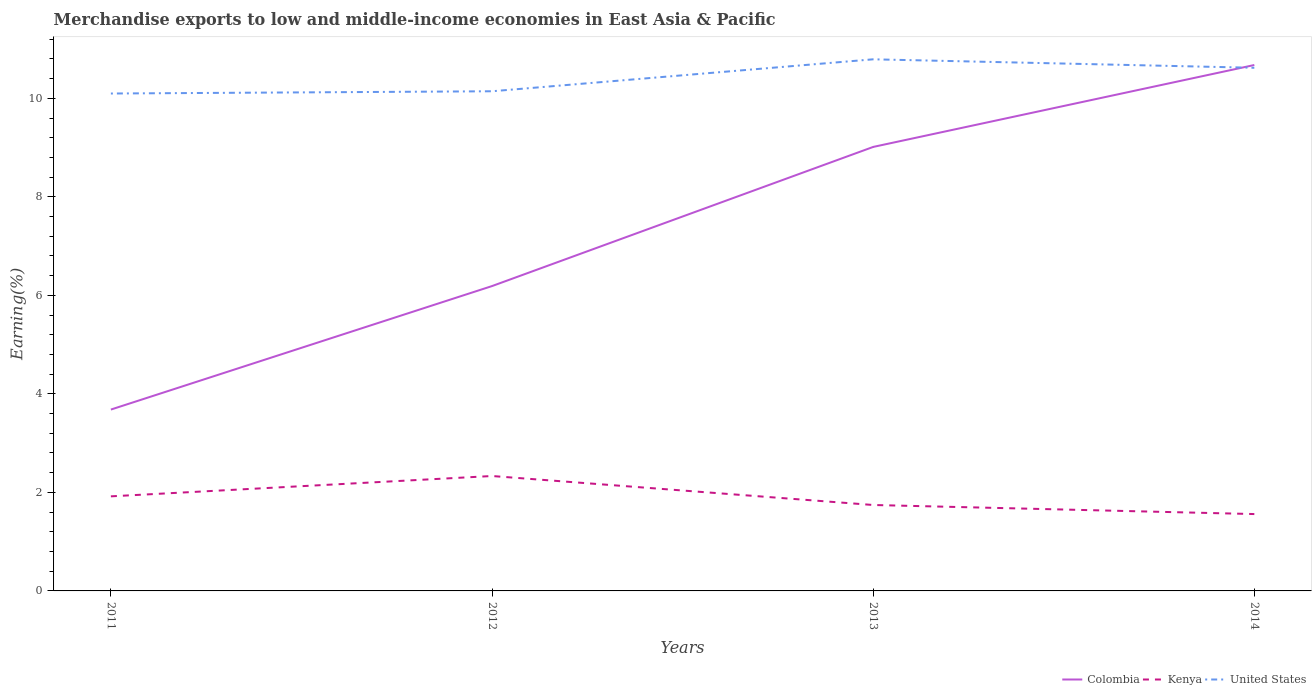Does the line corresponding to Kenya intersect with the line corresponding to Colombia?
Provide a short and direct response. No. Across all years, what is the maximum percentage of amount earned from merchandise exports in United States?
Provide a succinct answer. 10.1. What is the total percentage of amount earned from merchandise exports in United States in the graph?
Offer a very short reply. -0.65. What is the difference between the highest and the second highest percentage of amount earned from merchandise exports in Colombia?
Offer a very short reply. 6.99. What is the difference between the highest and the lowest percentage of amount earned from merchandise exports in Kenya?
Your answer should be very brief. 2. Is the percentage of amount earned from merchandise exports in United States strictly greater than the percentage of amount earned from merchandise exports in Colombia over the years?
Offer a terse response. No. How many lines are there?
Provide a succinct answer. 3. Are the values on the major ticks of Y-axis written in scientific E-notation?
Your answer should be compact. No. Where does the legend appear in the graph?
Keep it short and to the point. Bottom right. How are the legend labels stacked?
Make the answer very short. Horizontal. What is the title of the graph?
Provide a short and direct response. Merchandise exports to low and middle-income economies in East Asia & Pacific. What is the label or title of the X-axis?
Your answer should be compact. Years. What is the label or title of the Y-axis?
Your response must be concise. Earning(%). What is the Earning(%) in Colombia in 2011?
Provide a short and direct response. 3.68. What is the Earning(%) in Kenya in 2011?
Make the answer very short. 1.92. What is the Earning(%) in United States in 2011?
Provide a short and direct response. 10.1. What is the Earning(%) in Colombia in 2012?
Make the answer very short. 6.19. What is the Earning(%) in Kenya in 2012?
Your response must be concise. 2.33. What is the Earning(%) of United States in 2012?
Your answer should be compact. 10.14. What is the Earning(%) of Colombia in 2013?
Offer a very short reply. 9.01. What is the Earning(%) in Kenya in 2013?
Your response must be concise. 1.74. What is the Earning(%) of United States in 2013?
Provide a succinct answer. 10.79. What is the Earning(%) in Colombia in 2014?
Offer a terse response. 10.68. What is the Earning(%) in Kenya in 2014?
Your response must be concise. 1.56. What is the Earning(%) of United States in 2014?
Ensure brevity in your answer.  10.62. Across all years, what is the maximum Earning(%) of Colombia?
Provide a succinct answer. 10.68. Across all years, what is the maximum Earning(%) of Kenya?
Provide a short and direct response. 2.33. Across all years, what is the maximum Earning(%) in United States?
Make the answer very short. 10.79. Across all years, what is the minimum Earning(%) of Colombia?
Your answer should be compact. 3.68. Across all years, what is the minimum Earning(%) of Kenya?
Keep it short and to the point. 1.56. Across all years, what is the minimum Earning(%) of United States?
Offer a very short reply. 10.1. What is the total Earning(%) of Colombia in the graph?
Your response must be concise. 29.56. What is the total Earning(%) of Kenya in the graph?
Your response must be concise. 7.56. What is the total Earning(%) of United States in the graph?
Your response must be concise. 41.65. What is the difference between the Earning(%) in Colombia in 2011 and that in 2012?
Keep it short and to the point. -2.51. What is the difference between the Earning(%) in Kenya in 2011 and that in 2012?
Provide a succinct answer. -0.41. What is the difference between the Earning(%) in United States in 2011 and that in 2012?
Provide a short and direct response. -0.05. What is the difference between the Earning(%) in Colombia in 2011 and that in 2013?
Your response must be concise. -5.33. What is the difference between the Earning(%) of Kenya in 2011 and that in 2013?
Offer a very short reply. 0.18. What is the difference between the Earning(%) in United States in 2011 and that in 2013?
Ensure brevity in your answer.  -0.69. What is the difference between the Earning(%) of Colombia in 2011 and that in 2014?
Offer a terse response. -6.99. What is the difference between the Earning(%) of Kenya in 2011 and that in 2014?
Your answer should be very brief. 0.36. What is the difference between the Earning(%) in United States in 2011 and that in 2014?
Your answer should be compact. -0.52. What is the difference between the Earning(%) of Colombia in 2012 and that in 2013?
Offer a very short reply. -2.82. What is the difference between the Earning(%) of Kenya in 2012 and that in 2013?
Ensure brevity in your answer.  0.59. What is the difference between the Earning(%) in United States in 2012 and that in 2013?
Give a very brief answer. -0.65. What is the difference between the Earning(%) of Colombia in 2012 and that in 2014?
Provide a succinct answer. -4.49. What is the difference between the Earning(%) in Kenya in 2012 and that in 2014?
Ensure brevity in your answer.  0.77. What is the difference between the Earning(%) of United States in 2012 and that in 2014?
Provide a succinct answer. -0.48. What is the difference between the Earning(%) in Colombia in 2013 and that in 2014?
Offer a very short reply. -1.66. What is the difference between the Earning(%) in Kenya in 2013 and that in 2014?
Provide a succinct answer. 0.18. What is the difference between the Earning(%) of United States in 2013 and that in 2014?
Keep it short and to the point. 0.17. What is the difference between the Earning(%) of Colombia in 2011 and the Earning(%) of Kenya in 2012?
Provide a succinct answer. 1.35. What is the difference between the Earning(%) in Colombia in 2011 and the Earning(%) in United States in 2012?
Your answer should be very brief. -6.46. What is the difference between the Earning(%) of Kenya in 2011 and the Earning(%) of United States in 2012?
Offer a terse response. -8.22. What is the difference between the Earning(%) of Colombia in 2011 and the Earning(%) of Kenya in 2013?
Your answer should be compact. 1.94. What is the difference between the Earning(%) of Colombia in 2011 and the Earning(%) of United States in 2013?
Provide a succinct answer. -7.11. What is the difference between the Earning(%) in Kenya in 2011 and the Earning(%) in United States in 2013?
Ensure brevity in your answer.  -8.87. What is the difference between the Earning(%) of Colombia in 2011 and the Earning(%) of Kenya in 2014?
Provide a short and direct response. 2.12. What is the difference between the Earning(%) in Colombia in 2011 and the Earning(%) in United States in 2014?
Your response must be concise. -6.94. What is the difference between the Earning(%) in Kenya in 2011 and the Earning(%) in United States in 2014?
Keep it short and to the point. -8.7. What is the difference between the Earning(%) in Colombia in 2012 and the Earning(%) in Kenya in 2013?
Give a very brief answer. 4.44. What is the difference between the Earning(%) of Colombia in 2012 and the Earning(%) of United States in 2013?
Give a very brief answer. -4.6. What is the difference between the Earning(%) of Kenya in 2012 and the Earning(%) of United States in 2013?
Keep it short and to the point. -8.46. What is the difference between the Earning(%) in Colombia in 2012 and the Earning(%) in Kenya in 2014?
Provide a short and direct response. 4.63. What is the difference between the Earning(%) of Colombia in 2012 and the Earning(%) of United States in 2014?
Provide a short and direct response. -4.43. What is the difference between the Earning(%) of Kenya in 2012 and the Earning(%) of United States in 2014?
Your answer should be very brief. -8.29. What is the difference between the Earning(%) in Colombia in 2013 and the Earning(%) in Kenya in 2014?
Make the answer very short. 7.45. What is the difference between the Earning(%) of Colombia in 2013 and the Earning(%) of United States in 2014?
Your answer should be compact. -1.61. What is the difference between the Earning(%) in Kenya in 2013 and the Earning(%) in United States in 2014?
Keep it short and to the point. -8.88. What is the average Earning(%) of Colombia per year?
Give a very brief answer. 7.39. What is the average Earning(%) in Kenya per year?
Your answer should be very brief. 1.89. What is the average Earning(%) in United States per year?
Offer a very short reply. 10.41. In the year 2011, what is the difference between the Earning(%) in Colombia and Earning(%) in Kenya?
Ensure brevity in your answer.  1.76. In the year 2011, what is the difference between the Earning(%) in Colombia and Earning(%) in United States?
Provide a succinct answer. -6.42. In the year 2011, what is the difference between the Earning(%) in Kenya and Earning(%) in United States?
Keep it short and to the point. -8.18. In the year 2012, what is the difference between the Earning(%) of Colombia and Earning(%) of Kenya?
Offer a very short reply. 3.86. In the year 2012, what is the difference between the Earning(%) in Colombia and Earning(%) in United States?
Ensure brevity in your answer.  -3.95. In the year 2012, what is the difference between the Earning(%) of Kenya and Earning(%) of United States?
Offer a very short reply. -7.81. In the year 2013, what is the difference between the Earning(%) of Colombia and Earning(%) of Kenya?
Your answer should be compact. 7.27. In the year 2013, what is the difference between the Earning(%) in Colombia and Earning(%) in United States?
Your response must be concise. -1.78. In the year 2013, what is the difference between the Earning(%) of Kenya and Earning(%) of United States?
Your response must be concise. -9.05. In the year 2014, what is the difference between the Earning(%) of Colombia and Earning(%) of Kenya?
Give a very brief answer. 9.12. In the year 2014, what is the difference between the Earning(%) in Colombia and Earning(%) in United States?
Offer a terse response. 0.06. In the year 2014, what is the difference between the Earning(%) of Kenya and Earning(%) of United States?
Make the answer very short. -9.06. What is the ratio of the Earning(%) of Colombia in 2011 to that in 2012?
Provide a succinct answer. 0.59. What is the ratio of the Earning(%) of Kenya in 2011 to that in 2012?
Make the answer very short. 0.82. What is the ratio of the Earning(%) of Colombia in 2011 to that in 2013?
Your answer should be compact. 0.41. What is the ratio of the Earning(%) in Kenya in 2011 to that in 2013?
Your answer should be compact. 1.1. What is the ratio of the Earning(%) in United States in 2011 to that in 2013?
Keep it short and to the point. 0.94. What is the ratio of the Earning(%) in Colombia in 2011 to that in 2014?
Keep it short and to the point. 0.34. What is the ratio of the Earning(%) of Kenya in 2011 to that in 2014?
Provide a succinct answer. 1.23. What is the ratio of the Earning(%) of United States in 2011 to that in 2014?
Your answer should be very brief. 0.95. What is the ratio of the Earning(%) in Colombia in 2012 to that in 2013?
Provide a short and direct response. 0.69. What is the ratio of the Earning(%) of Kenya in 2012 to that in 2013?
Keep it short and to the point. 1.34. What is the ratio of the Earning(%) in United States in 2012 to that in 2013?
Keep it short and to the point. 0.94. What is the ratio of the Earning(%) of Colombia in 2012 to that in 2014?
Your response must be concise. 0.58. What is the ratio of the Earning(%) of Kenya in 2012 to that in 2014?
Provide a short and direct response. 1.5. What is the ratio of the Earning(%) of United States in 2012 to that in 2014?
Make the answer very short. 0.96. What is the ratio of the Earning(%) in Colombia in 2013 to that in 2014?
Provide a short and direct response. 0.84. What is the ratio of the Earning(%) in Kenya in 2013 to that in 2014?
Make the answer very short. 1.12. What is the ratio of the Earning(%) of United States in 2013 to that in 2014?
Offer a very short reply. 1.02. What is the difference between the highest and the second highest Earning(%) in Colombia?
Provide a short and direct response. 1.66. What is the difference between the highest and the second highest Earning(%) in Kenya?
Provide a succinct answer. 0.41. What is the difference between the highest and the second highest Earning(%) in United States?
Give a very brief answer. 0.17. What is the difference between the highest and the lowest Earning(%) in Colombia?
Offer a very short reply. 6.99. What is the difference between the highest and the lowest Earning(%) in Kenya?
Your answer should be compact. 0.77. What is the difference between the highest and the lowest Earning(%) in United States?
Keep it short and to the point. 0.69. 